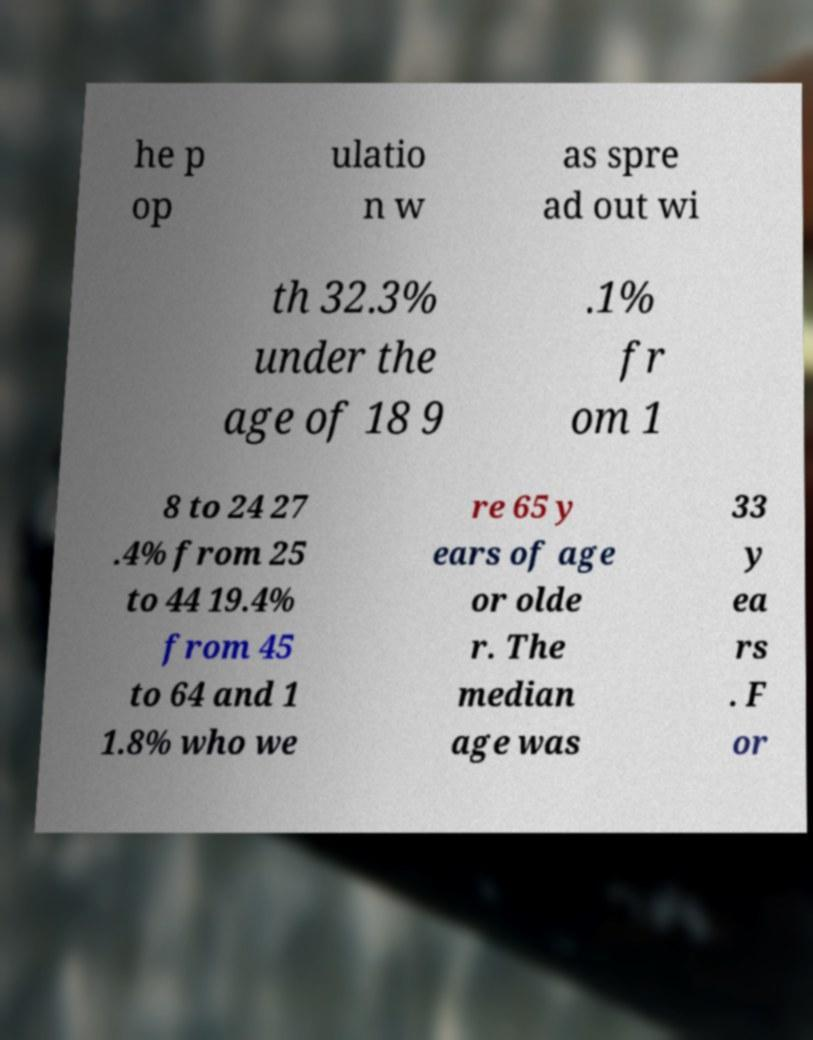Please read and relay the text visible in this image. What does it say? he p op ulatio n w as spre ad out wi th 32.3% under the age of 18 9 .1% fr om 1 8 to 24 27 .4% from 25 to 44 19.4% from 45 to 64 and 1 1.8% who we re 65 y ears of age or olde r. The median age was 33 y ea rs . F or 